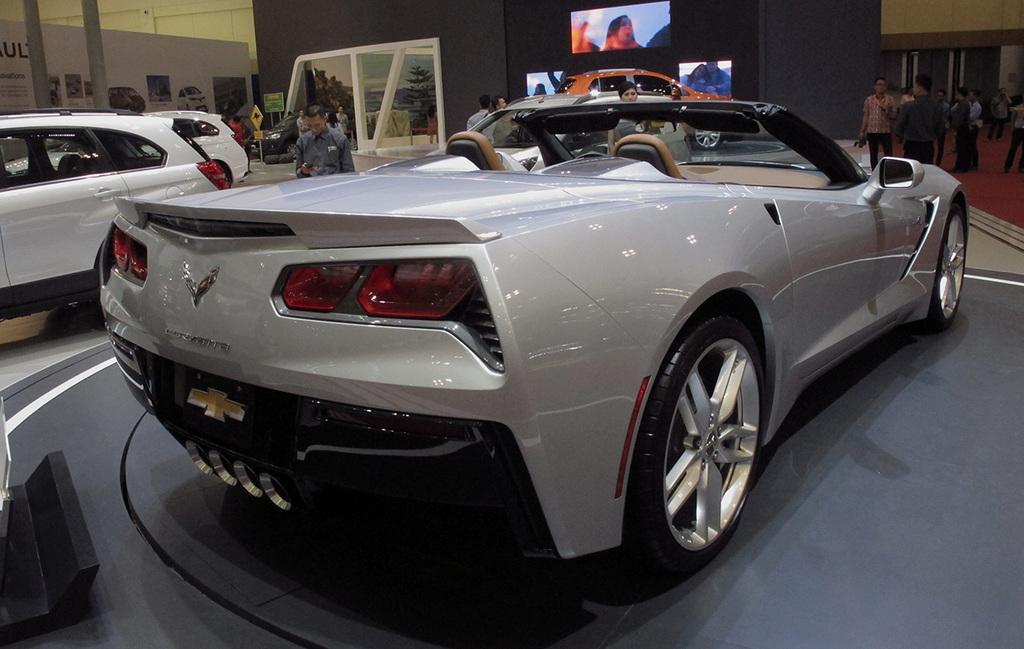Please provide a concise description of this image. In this picture we can see inside view of the car showroom. In the front we can see silver car is parked. Behind we can we see some television screens on the black wall. 